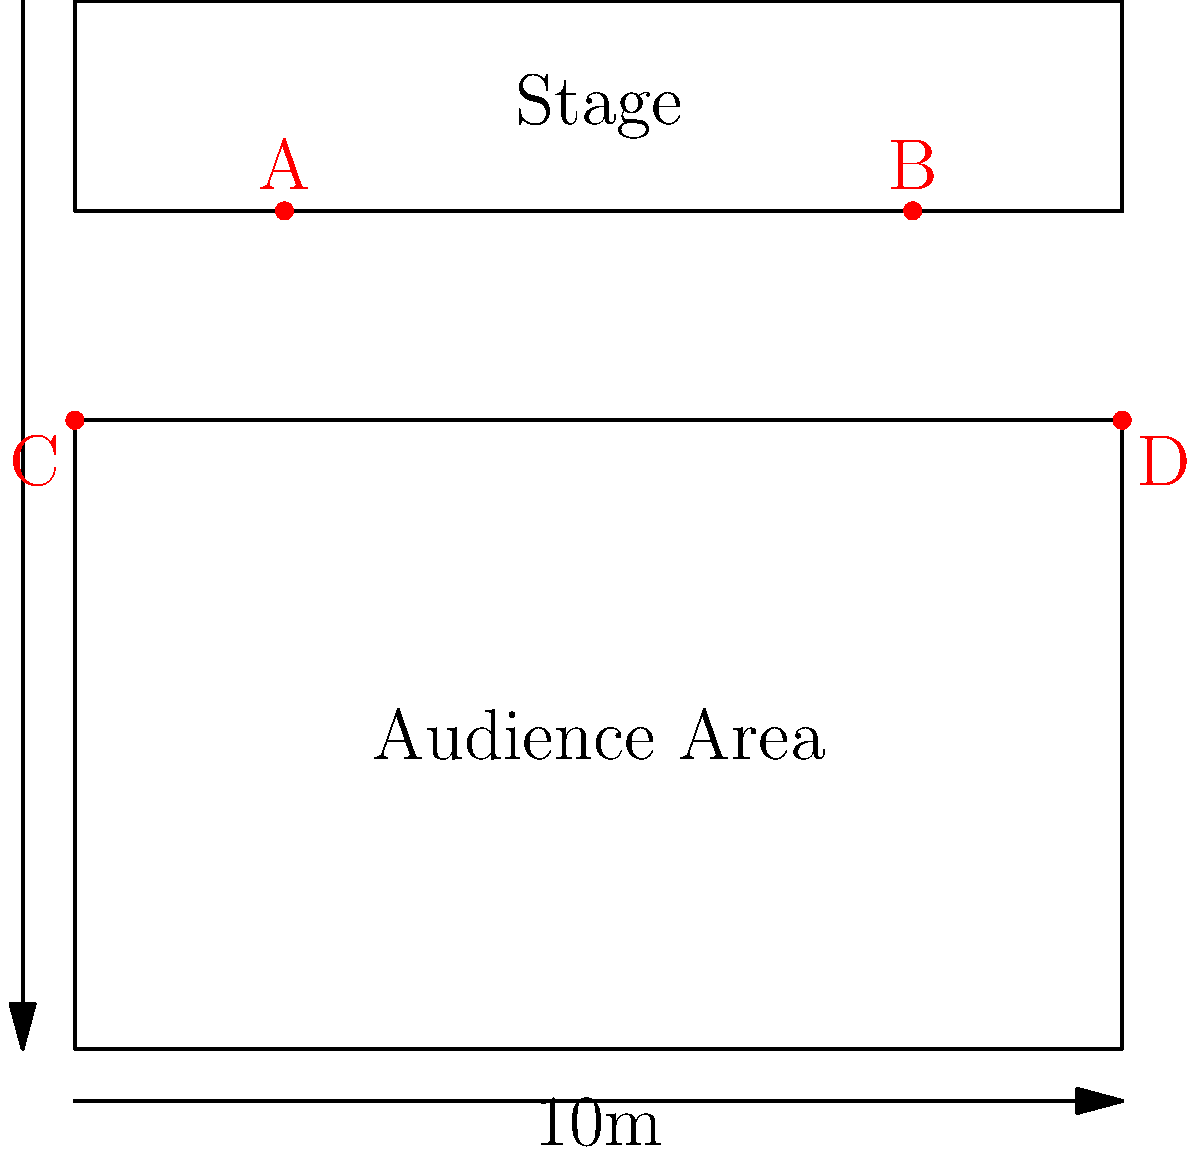Based on the venue map provided, which speaker placement configuration would likely provide the most even sound distribution for the outdoor Hawaiian music performance? Consider that the goal is to maximize coverage and minimize audio "dead spots" in the audience area. To determine the optimal speaker placement for even sound distribution, we need to consider several factors:

1. Coverage area: The speakers should cover the entire audience area uniformly.

2. Sound overlap: There should be a balanced overlap of sound from different speakers to avoid dead spots.

3. Distance from the stage: Speakers closer to the stage can reinforce the sound for the audience in the front, while those further back can cover the rear of the audience.

4. Symmetry: A symmetrical layout often provides more consistent sound coverage.

Given the venue map:

1. Speakers A and B are on the stage, which can provide good coverage for the front of the audience and reinforce the on-stage sound.

2. Speakers C and D are placed at the rear corners of the audience area, which can provide coverage for the back of the audience.

3. The placement creates a symmetrical layout, with two speakers on the stage and two at the rear corners of the audience area.

4. This configuration allows for sound to be distributed from both the front and back of the venue, creating an overlap in the middle of the audience area.

5. The distance between the front and rear speakers (approximately 10m) is appropriate for the size of the venue, allowing for good sound distribution without excessive delay between front and rear speakers.

This speaker placement utilizes the concept of a distributed sound system, where multiple speakers are used to cover different areas of the venue. It's particularly effective for outdoor venues where sound can dissipate quickly.

The configuration shown in the map (A, B, C, and D) provides a balanced and symmetrical layout that would likely result in the most even sound distribution for the audience, minimizing dead spots and ensuring good coverage throughout the venue.
Answer: The configuration shown (A, B, C, and D) 